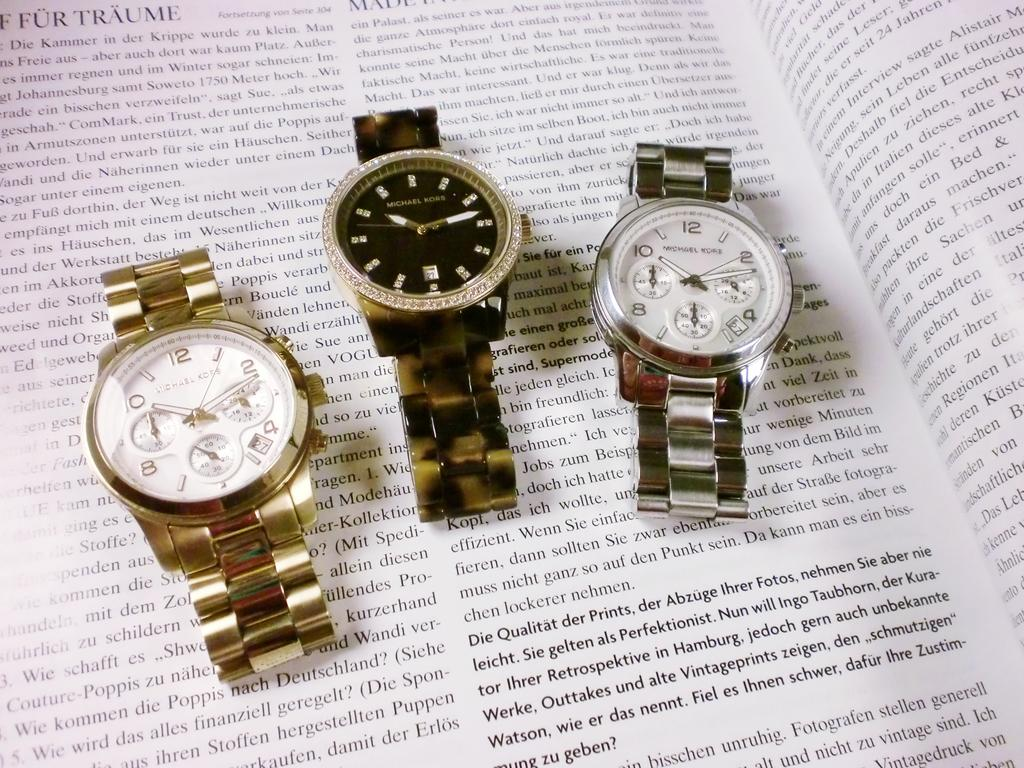<image>
Describe the image concisely. Three Michael Kors watches are laying on an open book. 